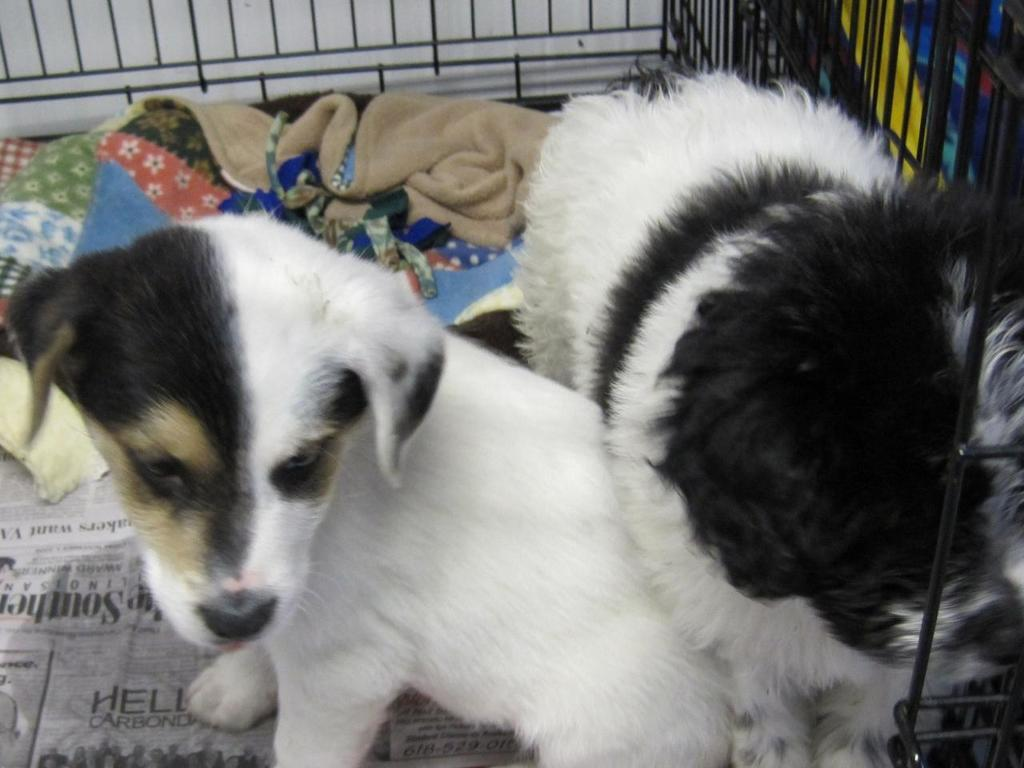What type of animal is in the image? There is a dog in the image. What colors can be seen on the dog? The dog is white, black, and cream in color. Where is the dog located in the image? The dog is in a black-colored metal cage. What else can be seen in the cage besides the dog? There are clothes and papers in the cage. What type of coast can be seen in the image? There is no coast visible in the image; it features a dog in a cage with clothes and papers. Is there a crack in the cage that the dog is in? There is no mention of a crack in the cage in the provided facts, so we cannot determine if there is one or not. 